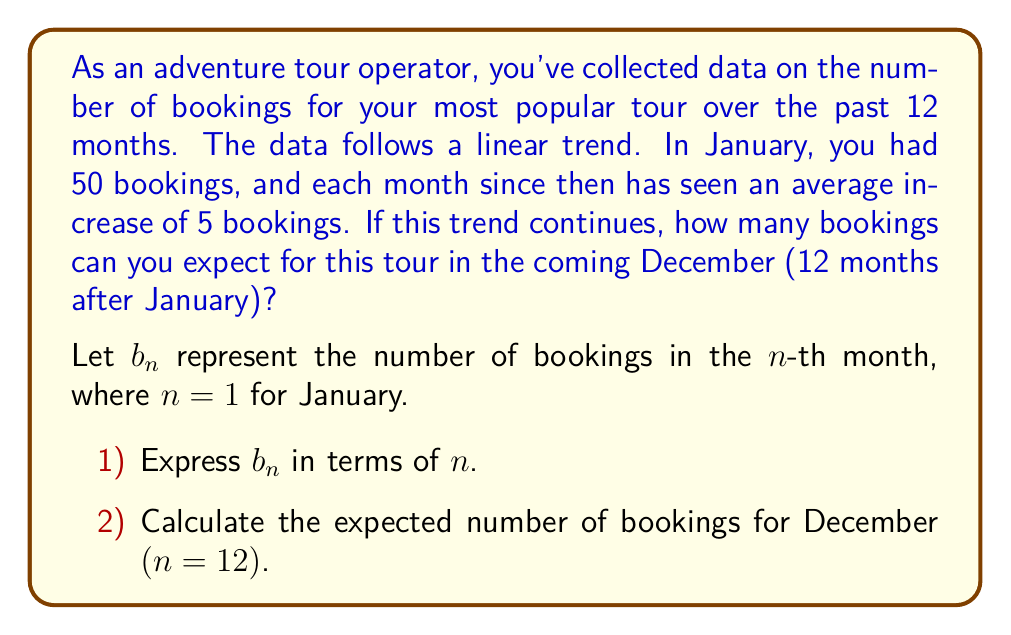Show me your answer to this math problem. To solve this problem, we'll use linear equations and arithmetic sequences.

1) Expressing $b_n$ in terms of $n$:

   We know that the initial value (January, $n = 1$) is 50 bookings, and there's an increase of 5 bookings each month.
   
   This forms an arithmetic sequence with:
   - First term $a_1 = 50$
   - Common difference $d = 5$
   
   The general term of an arithmetic sequence is given by:
   
   $$b_n = a_1 + (n-1)d$$
   
   Substituting our values:
   
   $$b_n = 50 + (n-1)5$$
   
   Simplifying:
   
   $$b_n = 50 + 5n - 5 = 5n + 45$$

2) Calculating bookings for December $(n = 12)$:

   We can now substitute $n = 12$ into our equation:
   
   $$b_{12} = 5(12) + 45$$
   
   $$b_{12} = 60 + 45 = 105$$

Therefore, if the trend continues, you can expect 105 bookings for your tour in December.
Answer: 105 bookings 